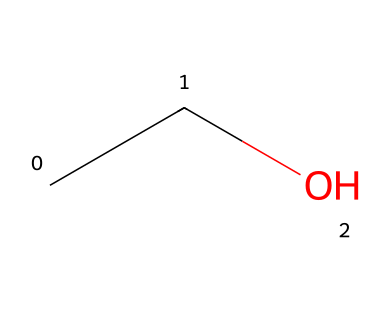What is the name of this chemical? The SMILES representation "CCO" corresponds to ethanol, which is widely known for its use in hand sanitizers.
Answer: ethanol How many carbon atoms are present in this structure? By analyzing the SMILES "CCO," there are two "C" characters, which represent two carbon atoms in the molecular structure.
Answer: 2 What is the total number of hydrogen atoms in this molecule? Each carbon atom ordinarily bonds with hydrogen atoms to fulfill the tetravalency; here, the two carbon atoms are bonded to a total of five hydrogen atoms, getting one from the terminal carbon and two from the second carbon.
Answer: 6 Is this solvent polar or non-polar? The chemical structure presents a hydroxyl (-OH) group; the presence of this functional group indicates that ethanol is polar.
Answer: polar What type of functional group is present in ethanol? The presence of the -OH group in the SMILES representation corresponds to an alcohol functional group, which characterizes ethanol.
Answer: alcohol What is the primary use of ethanol in the context of sanitizers? Ethanol is primarily used in hand sanitizers due to its effectiveness in killing bacteria and viruses through its high evaporative rate and ability to denature proteins.
Answer: disinfectant What state of matter is ethanol typically found in at room temperature? Ethanol, as indicated by its chemical structure and properties, is a liquid at room temperature due to its relatively low molecular weight and vibrational energy levels.
Answer: liquid 